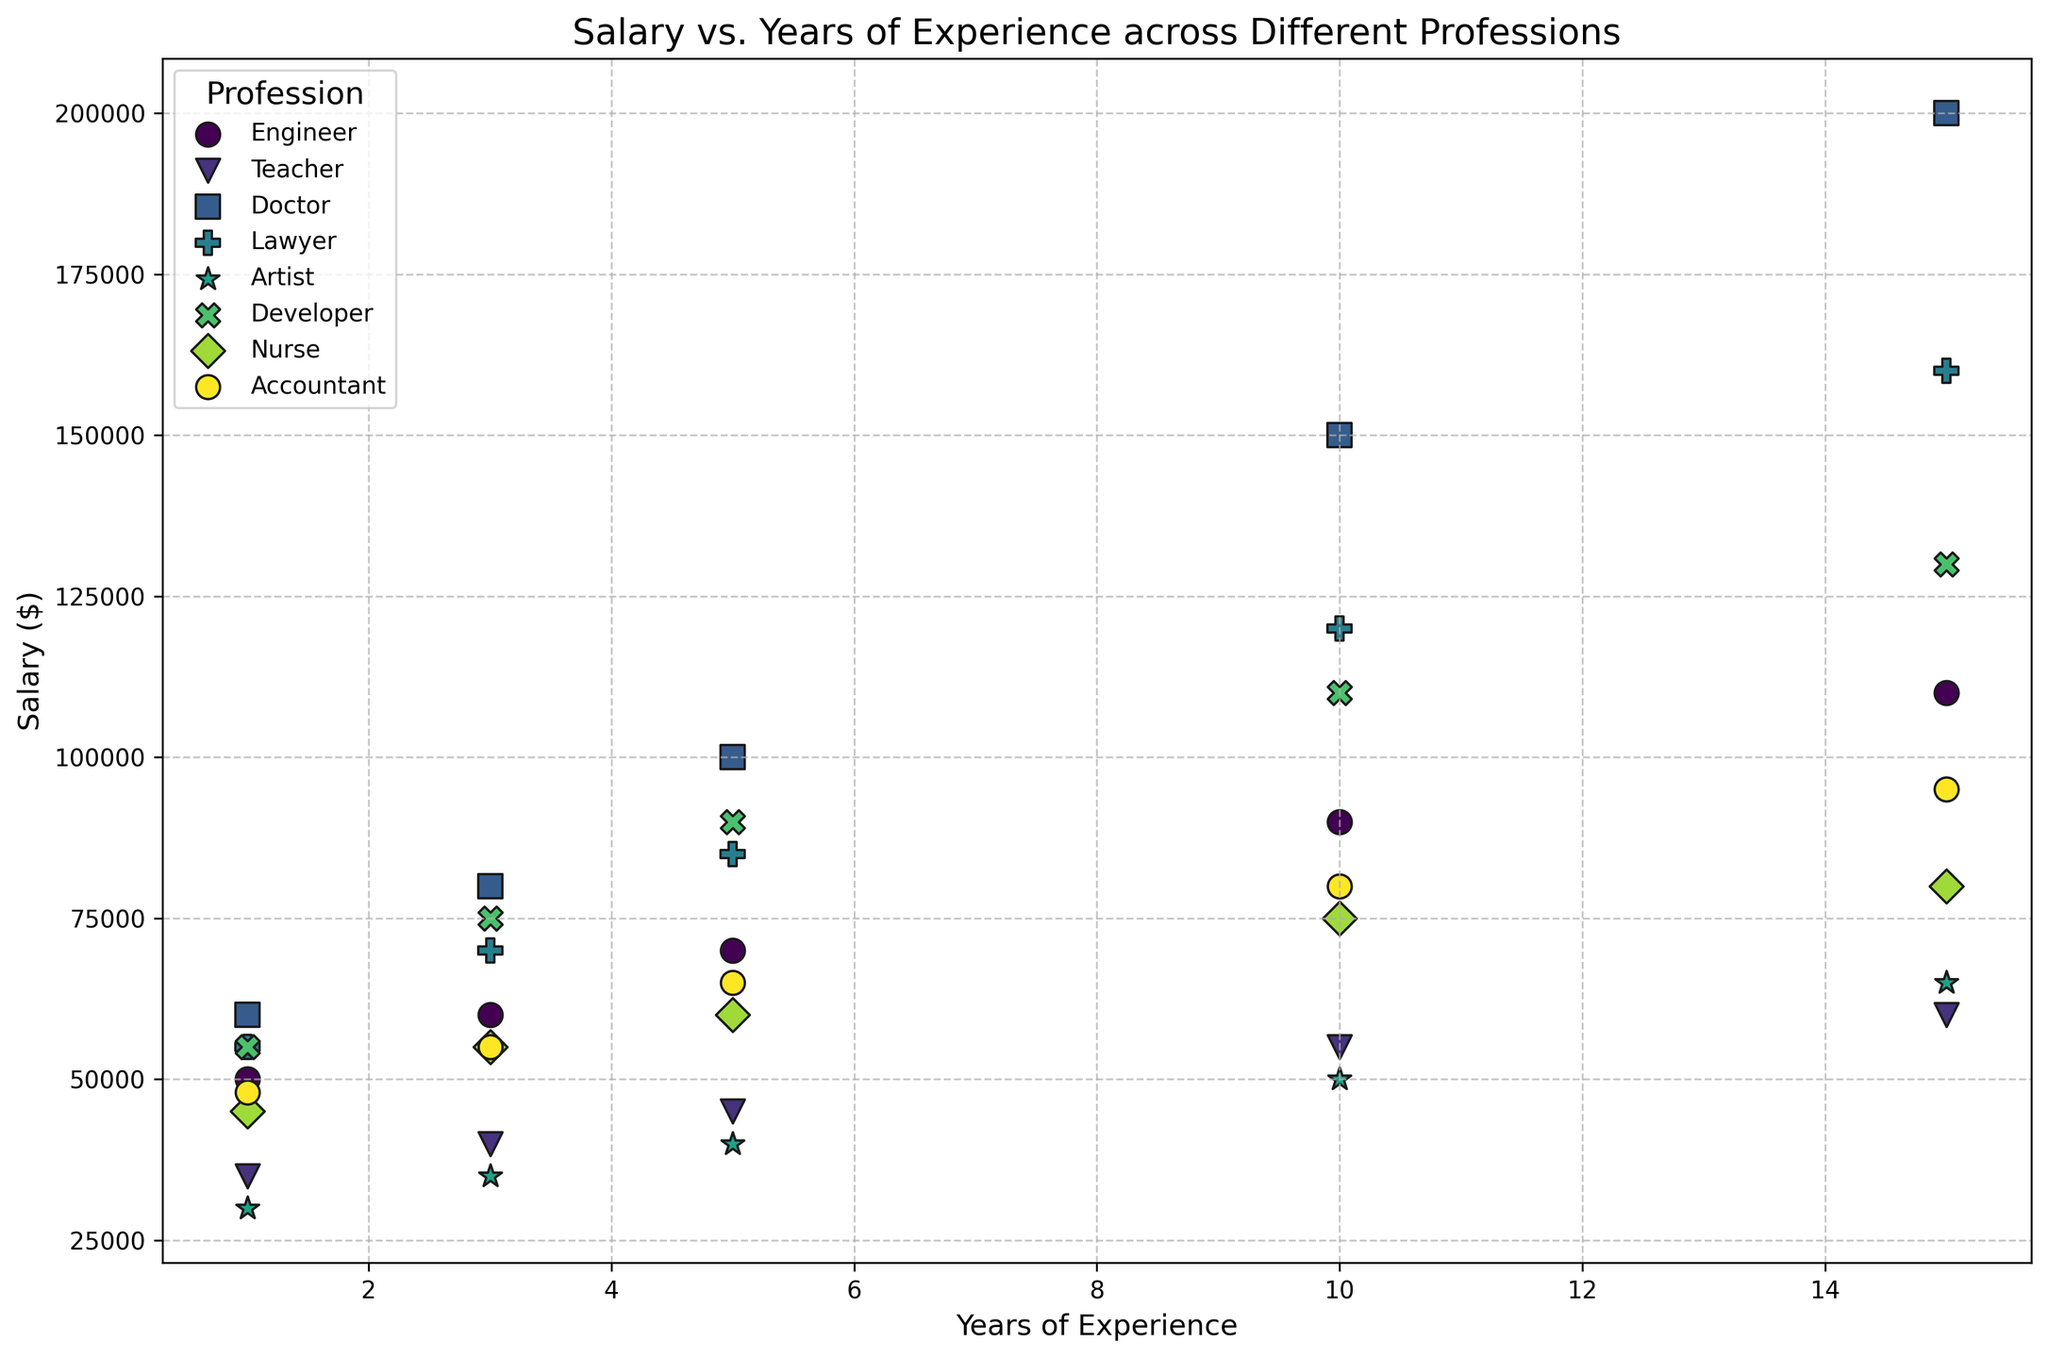What is the profession with the highest salary at 10 years of experience? Identify the data points for each profession at 10 years of experience. Compare the salaries and find the one with the highest value.
Answer: Doctor Which profession has the steepest increase in salary between 1 and 15 years of experience? Calculate the salary differences for each profession between 1 and 15 years of experience. The profession with the largest difference has the steepest increase.
Answer: Doctor Among professions with 5 years of experience, which one has a lower salary: Teacher or Nurse? Locate the data points for Teacher and Nurse at 5 years of experience. Compare their salaries to determine which is lower.
Answer: Teacher Which professions have a higher salary than Teachers at every data point (1, 3, 5, 10, and 15 years)? Compare the Teacher's salary at 1, 3, 5, 10, and 15 years with those of other professions at the same points. Identify professions that consistently show higher salaries.
Answer: Engineer, Doctor, Lawyer, Developer What is the average salary for Artists over the given years of experience? Sum the salaries for Artists at 1, 3, 5, 10, and 15 years of experience. Divide the total by the number of data points (5). Average = (30000 + 35000 + 40000 + 50000 + 65000) / 5 = 44000
Answer: 44000 How does the salary at 3 years of experience for Developers compare to Accountants? Find the salary data points for Developers and Accountants at 3 years of experience. Compare these values to see which is higher.
Answer: Developers have higher salaries How many professions have a salary of at least $100,000 at 10 years of experience? Identify the data points for each profession at 10 years of experience. Count those with a salary of $100,000 or more.
Answer: 4 (Engineer, Doctor, Lawyer, Developer) Is there any profession where the increase in salary from 5 years to 10 years is greater than from 10 years to 15 years? Calculate the salary increases for each profession from 5 to 10 years and 10 to 15 years. Compare these values for each profession.
Answer: Engineer, Developer 